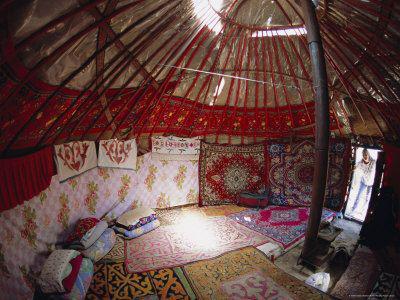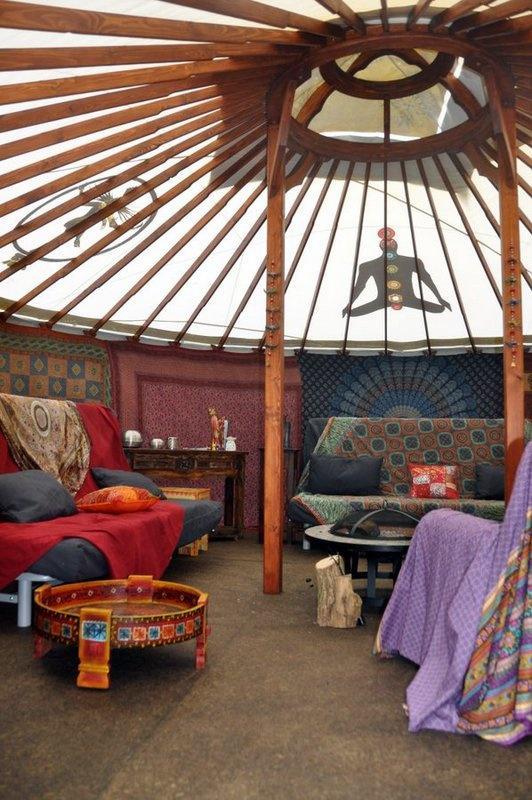The first image is the image on the left, the second image is the image on the right. Analyze the images presented: Is the assertion "At least one image shows a building in a snowy setting." valid? Answer yes or no. No. The first image is the image on the left, the second image is the image on the right. Considering the images on both sides, is "Both images are interior shots of round houses." valid? Answer yes or no. Yes. 